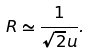<formula> <loc_0><loc_0><loc_500><loc_500>R \simeq \frac { 1 } { \sqrt { 2 } u } .</formula> 